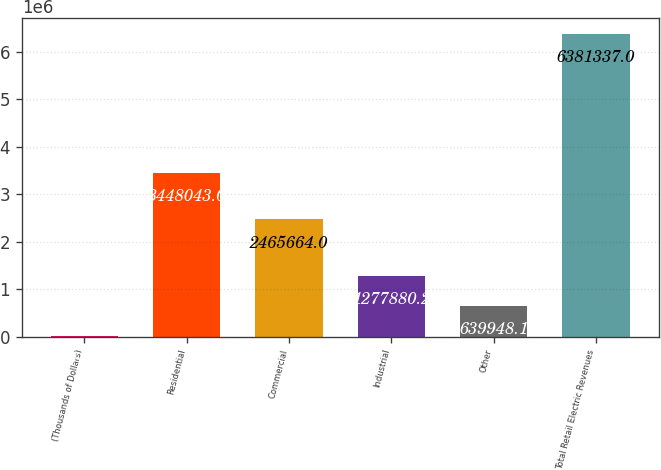<chart> <loc_0><loc_0><loc_500><loc_500><bar_chart><fcel>(Thousands of Dollars)<fcel>Residential<fcel>Commercial<fcel>Industrial<fcel>Other<fcel>Total Retail Electric Revenues<nl><fcel>2016<fcel>3.44804e+06<fcel>2.46566e+06<fcel>1.27788e+06<fcel>639948<fcel>6.38134e+06<nl></chart> 